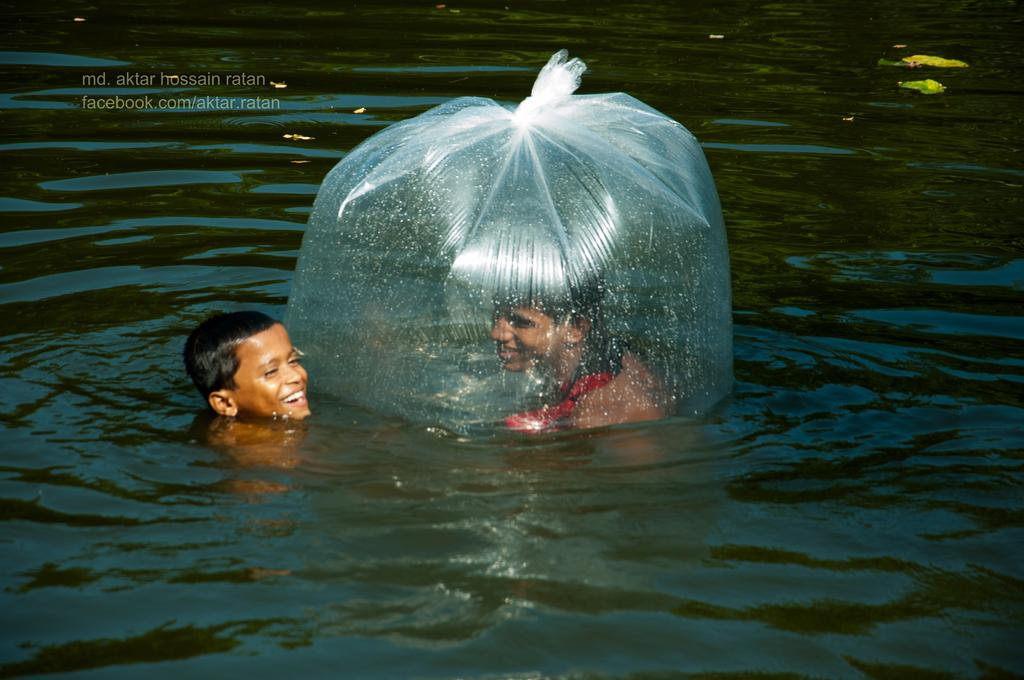How many people are in the water in the image? There are two persons in the water in the image. What is the condition of one of the persons in the water? One person is inside a cover. Can you describe any text visible in the image? There is some text visible at the top of the image. What type of pollution can be seen in the water in the image? There is no pollution visible in the water in the image. Can you describe the snail's behavior in the image? There are no snails present in the image. 